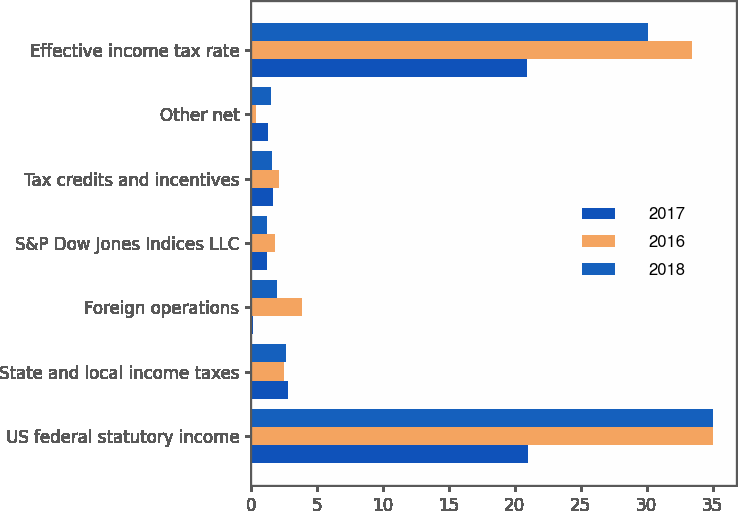<chart> <loc_0><loc_0><loc_500><loc_500><stacked_bar_chart><ecel><fcel>US federal statutory income<fcel>State and local income taxes<fcel>Foreign operations<fcel>S&P Dow Jones Indices LLC<fcel>Tax credits and incentives<fcel>Other net<fcel>Effective income tax rate<nl><fcel>2017<fcel>21<fcel>2.8<fcel>0.2<fcel>1.2<fcel>1.7<fcel>1.3<fcel>20.9<nl><fcel>2016<fcel>35<fcel>2.5<fcel>3.9<fcel>1.8<fcel>2.1<fcel>0.4<fcel>33.4<nl><fcel>2018<fcel>35<fcel>2.7<fcel>2<fcel>1.2<fcel>1.6<fcel>1.5<fcel>30.1<nl></chart> 